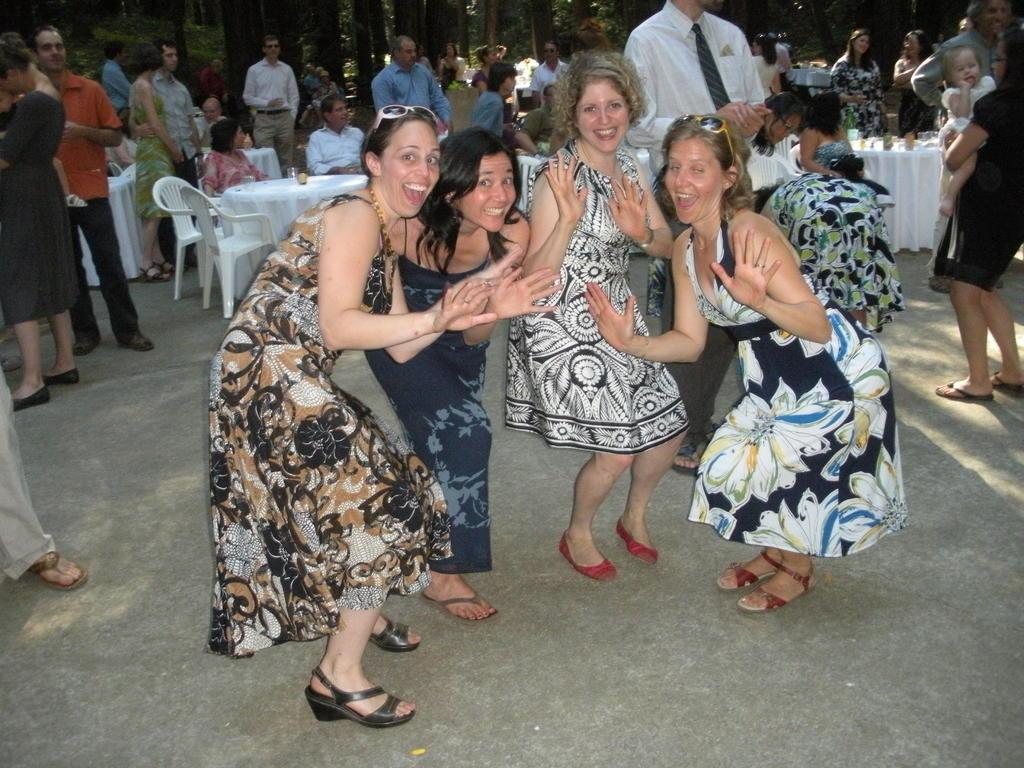What type of people can be seen in the image? There are women standing in the image. How many individuals are present in the image? There are persons in the image. What type of furniture is visible in the image? There are chairs and tables in the image. What can be seen in the background of the image? Trees are visible in the background of the image. Can you tell me how many volcanoes are visible in the image? There are no volcanoes present in the image. What type of insect can be seen crawling on the table in the image? There is no insect visible in the image; only women, chairs, tables, and trees are present. 